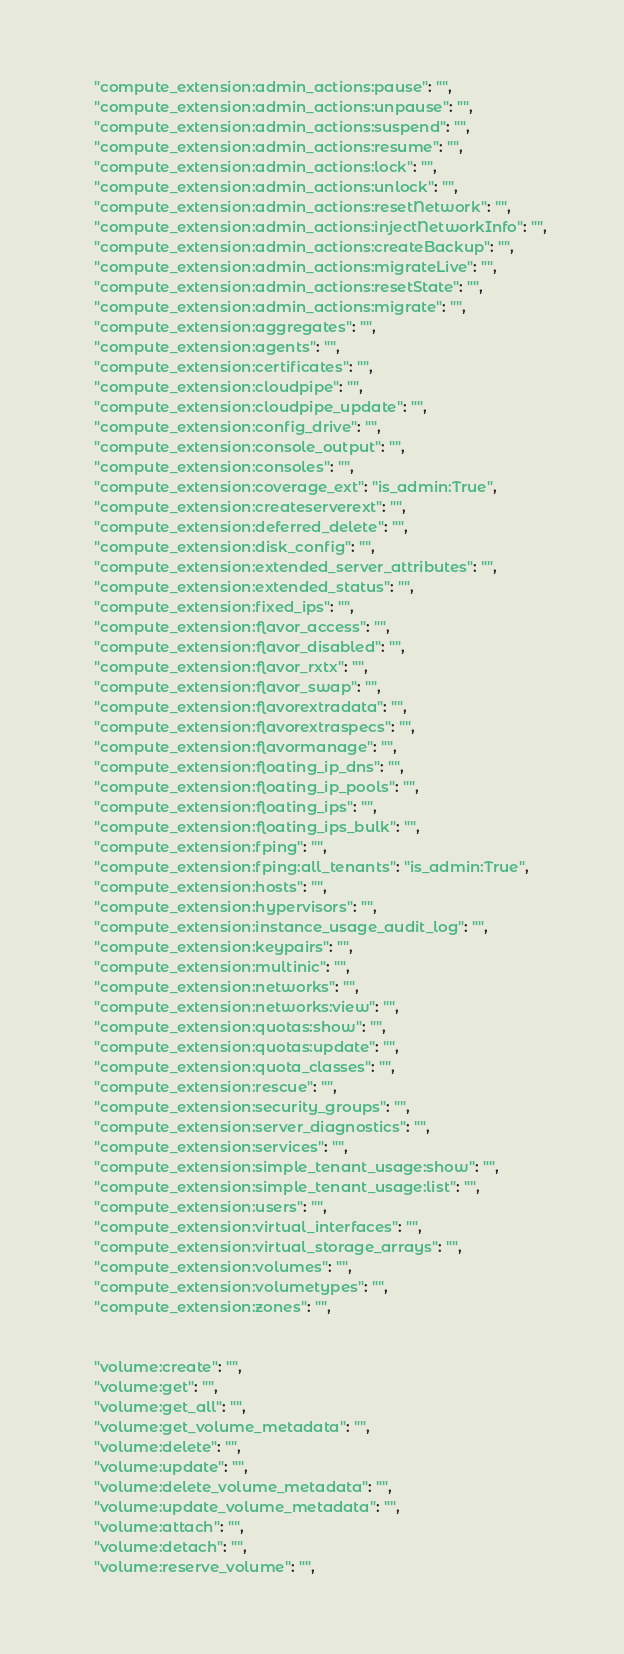<code> <loc_0><loc_0><loc_500><loc_500><_Python_>    "compute_extension:admin_actions:pause": "",
    "compute_extension:admin_actions:unpause": "",
    "compute_extension:admin_actions:suspend": "",
    "compute_extension:admin_actions:resume": "",
    "compute_extension:admin_actions:lock": "",
    "compute_extension:admin_actions:unlock": "",
    "compute_extension:admin_actions:resetNetwork": "",
    "compute_extension:admin_actions:injectNetworkInfo": "",
    "compute_extension:admin_actions:createBackup": "",
    "compute_extension:admin_actions:migrateLive": "",
    "compute_extension:admin_actions:resetState": "",
    "compute_extension:admin_actions:migrate": "",
    "compute_extension:aggregates": "",
    "compute_extension:agents": "",
    "compute_extension:certificates": "",
    "compute_extension:cloudpipe": "",
    "compute_extension:cloudpipe_update": "",
    "compute_extension:config_drive": "",
    "compute_extension:console_output": "",
    "compute_extension:consoles": "",
    "compute_extension:coverage_ext": "is_admin:True",
    "compute_extension:createserverext": "",
    "compute_extension:deferred_delete": "",
    "compute_extension:disk_config": "",
    "compute_extension:extended_server_attributes": "",
    "compute_extension:extended_status": "",
    "compute_extension:fixed_ips": "",
    "compute_extension:flavor_access": "",
    "compute_extension:flavor_disabled": "",
    "compute_extension:flavor_rxtx": "",
    "compute_extension:flavor_swap": "",
    "compute_extension:flavorextradata": "",
    "compute_extension:flavorextraspecs": "",
    "compute_extension:flavormanage": "",
    "compute_extension:floating_ip_dns": "",
    "compute_extension:floating_ip_pools": "",
    "compute_extension:floating_ips": "",
    "compute_extension:floating_ips_bulk": "",
    "compute_extension:fping": "",
    "compute_extension:fping:all_tenants": "is_admin:True",
    "compute_extension:hosts": "",
    "compute_extension:hypervisors": "",
    "compute_extension:instance_usage_audit_log": "",
    "compute_extension:keypairs": "",
    "compute_extension:multinic": "",
    "compute_extension:networks": "",
    "compute_extension:networks:view": "",
    "compute_extension:quotas:show": "",
    "compute_extension:quotas:update": "",
    "compute_extension:quota_classes": "",
    "compute_extension:rescue": "",
    "compute_extension:security_groups": "",
    "compute_extension:server_diagnostics": "",
    "compute_extension:services": "",
    "compute_extension:simple_tenant_usage:show": "",
    "compute_extension:simple_tenant_usage:list": "",
    "compute_extension:users": "",
    "compute_extension:virtual_interfaces": "",
    "compute_extension:virtual_storage_arrays": "",
    "compute_extension:volumes": "",
    "compute_extension:volumetypes": "",
    "compute_extension:zones": "",


    "volume:create": "",
    "volume:get": "",
    "volume:get_all": "",
    "volume:get_volume_metadata": "",
    "volume:delete": "",
    "volume:update": "",
    "volume:delete_volume_metadata": "",
    "volume:update_volume_metadata": "",
    "volume:attach": "",
    "volume:detach": "",
    "volume:reserve_volume": "",</code> 